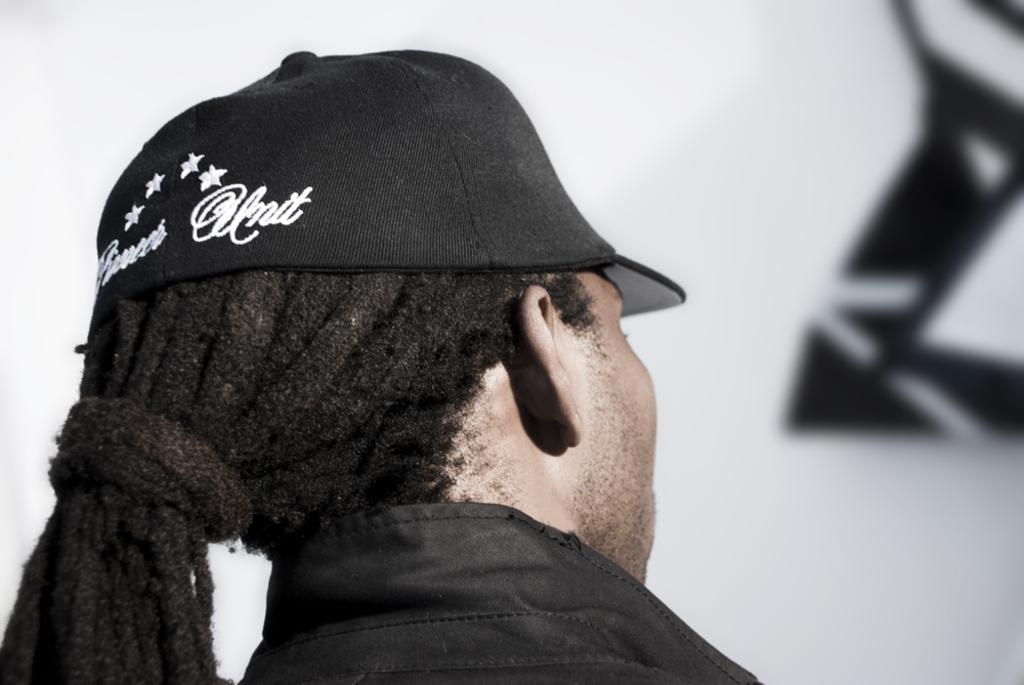What is present in the image? There is a person in the image. Can you describe the person's attire? The person is wearing clothes and a cap. What can be observed about the background of the image? The background of the image is white with a black design. How does the person contribute to reducing pollution in the image? There is no indication of pollution or any actions related to pollution in the image. 